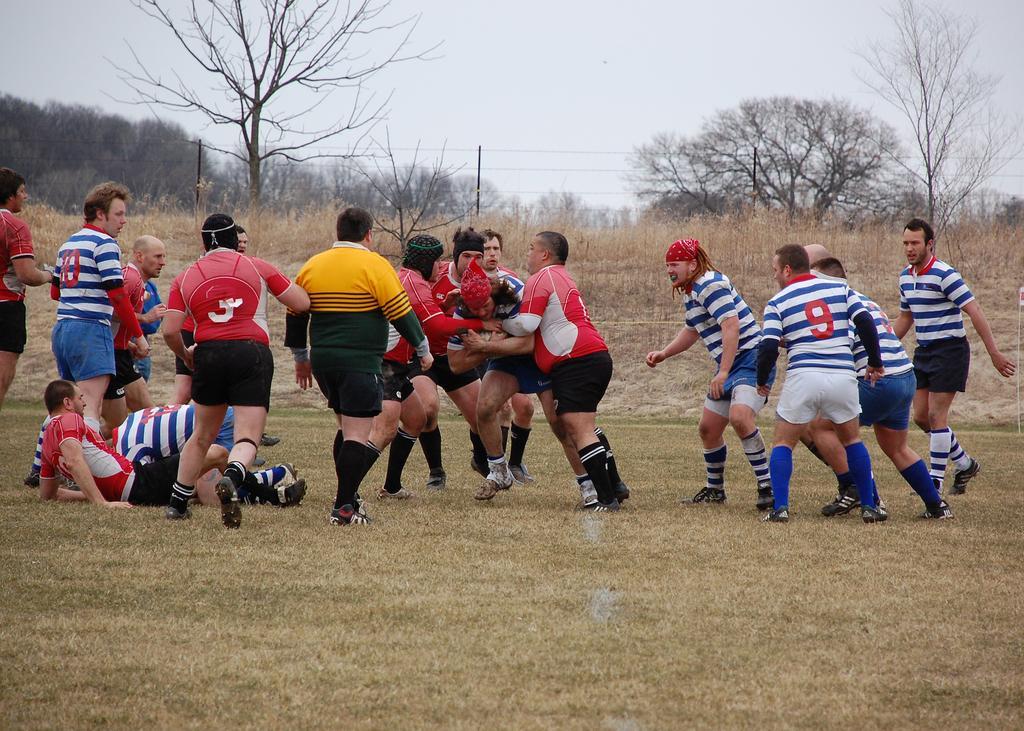Can you describe this image briefly? In this image we can see few people on the ground and in the background there are few trees, pole with wires and the sky. 